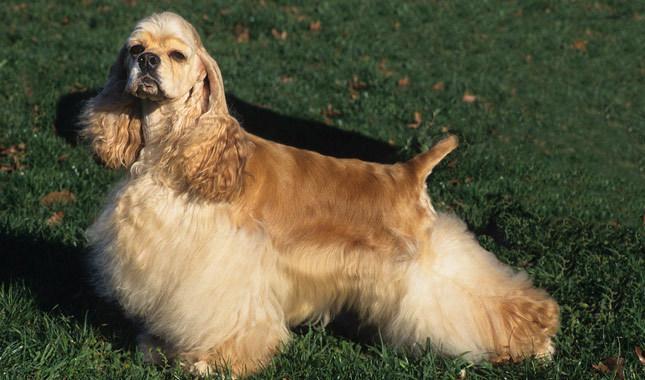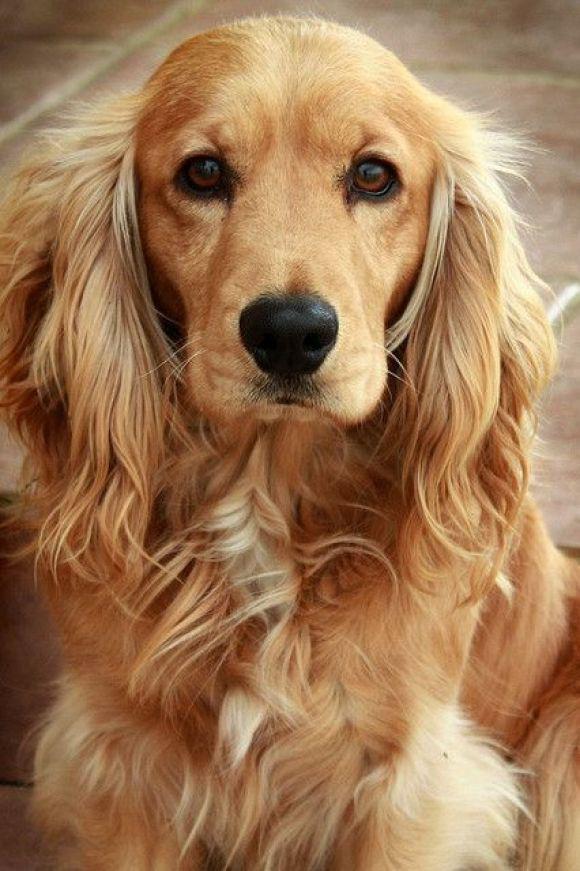The first image is the image on the left, the second image is the image on the right. For the images shown, is this caption "The dog in the left image has a hair decoration." true? Answer yes or no. No. 